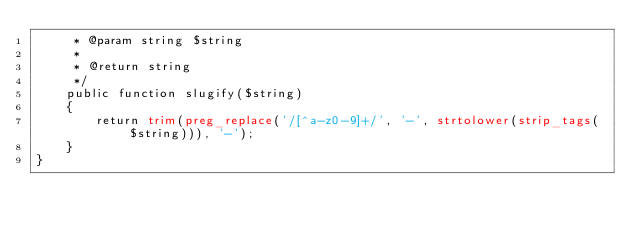Convert code to text. <code><loc_0><loc_0><loc_500><loc_500><_PHP_>     * @param string $string
     *
     * @return string
     */
    public function slugify($string)
    {
        return trim(preg_replace('/[^a-z0-9]+/', '-', strtolower(strip_tags($string))), '-');
    }
}
</code> 